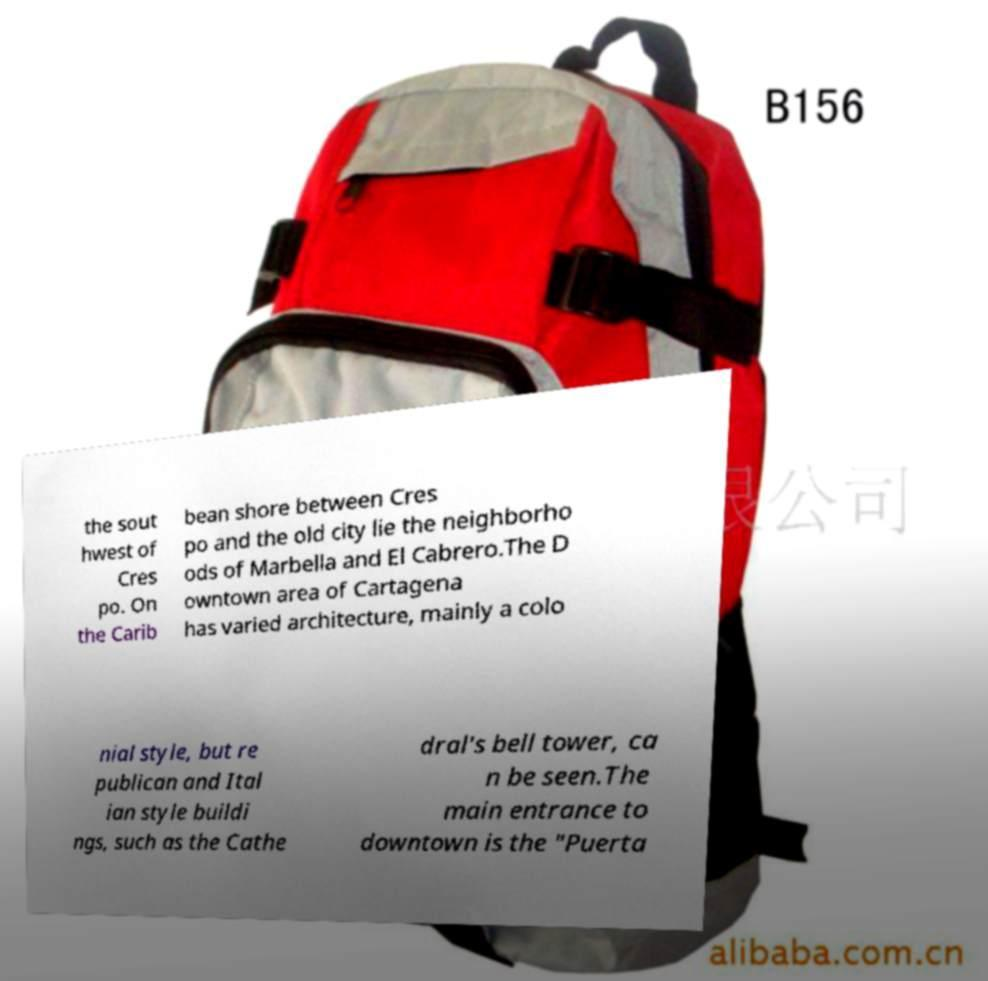Can you accurately transcribe the text from the provided image for me? the sout hwest of Cres po. On the Carib bean shore between Cres po and the old city lie the neighborho ods of Marbella and El Cabrero.The D owntown area of Cartagena has varied architecture, mainly a colo nial style, but re publican and Ital ian style buildi ngs, such as the Cathe dral's bell tower, ca n be seen.The main entrance to downtown is the "Puerta 